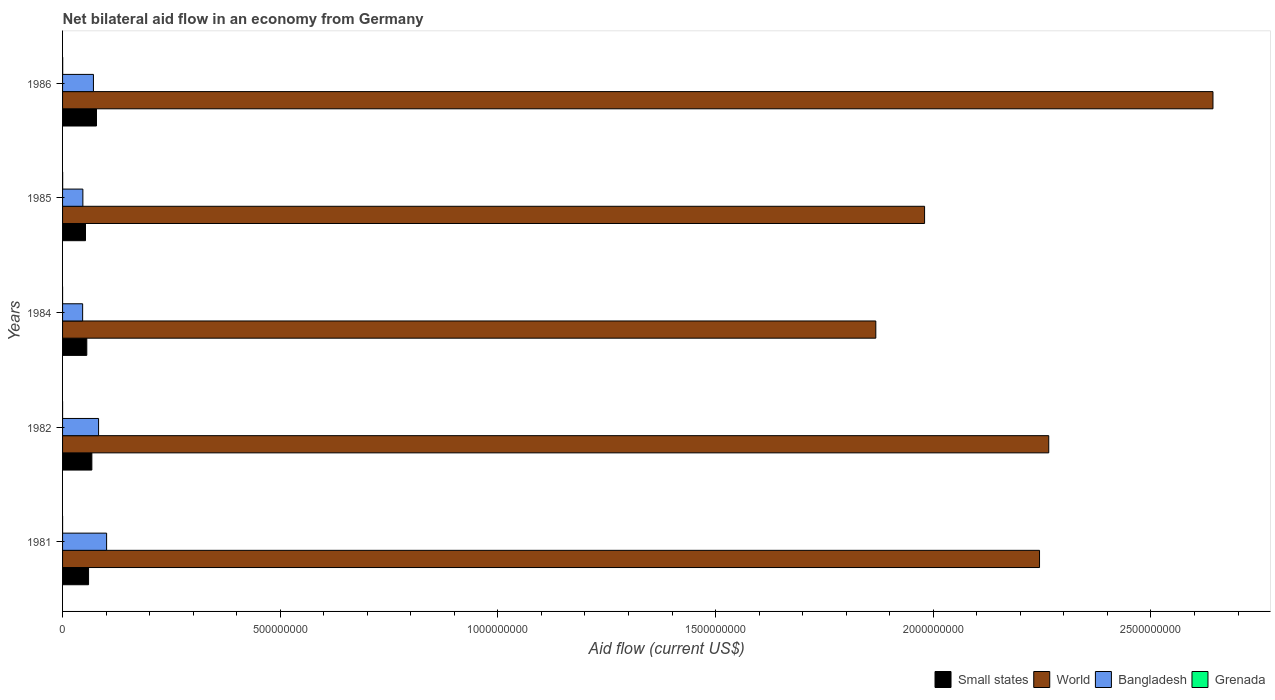Are the number of bars per tick equal to the number of legend labels?
Provide a succinct answer. Yes. How many bars are there on the 4th tick from the bottom?
Your answer should be very brief. 4. What is the label of the 5th group of bars from the top?
Give a very brief answer. 1981. In how many cases, is the number of bars for a given year not equal to the number of legend labels?
Your answer should be compact. 0. What is the net bilateral aid flow in World in 1985?
Provide a short and direct response. 1.98e+09. Across all years, what is the maximum net bilateral aid flow in Small states?
Your response must be concise. 7.79e+07. Across all years, what is the minimum net bilateral aid flow in Small states?
Make the answer very short. 5.27e+07. In which year was the net bilateral aid flow in Small states maximum?
Offer a very short reply. 1986. What is the total net bilateral aid flow in Bangladesh in the graph?
Keep it short and to the point. 3.48e+08. What is the difference between the net bilateral aid flow in Bangladesh in 1981 and the net bilateral aid flow in World in 1985?
Keep it short and to the point. -1.88e+09. What is the average net bilateral aid flow in Small states per year?
Keep it short and to the point. 6.27e+07. In the year 1985, what is the difference between the net bilateral aid flow in World and net bilateral aid flow in Grenada?
Make the answer very short. 1.98e+09. In how many years, is the net bilateral aid flow in Small states greater than 1400000000 US$?
Offer a terse response. 0. What is the ratio of the net bilateral aid flow in Small states in 1982 to that in 1986?
Your answer should be compact. 0.86. Is the difference between the net bilateral aid flow in World in 1981 and 1984 greater than the difference between the net bilateral aid flow in Grenada in 1981 and 1984?
Your answer should be very brief. Yes. What is the difference between the highest and the second highest net bilateral aid flow in Bangladesh?
Provide a short and direct response. 1.85e+07. What is the difference between the highest and the lowest net bilateral aid flow in Bangladesh?
Your response must be concise. 5.51e+07. Is it the case that in every year, the sum of the net bilateral aid flow in Small states and net bilateral aid flow in World is greater than the sum of net bilateral aid flow in Grenada and net bilateral aid flow in Bangladesh?
Keep it short and to the point. Yes. What does the 3rd bar from the top in 1985 represents?
Provide a short and direct response. World. What does the 4th bar from the bottom in 1982 represents?
Your answer should be compact. Grenada. Is it the case that in every year, the sum of the net bilateral aid flow in World and net bilateral aid flow in Bangladesh is greater than the net bilateral aid flow in Grenada?
Your answer should be compact. Yes. What is the difference between two consecutive major ticks on the X-axis?
Give a very brief answer. 5.00e+08. Does the graph contain any zero values?
Make the answer very short. No. Does the graph contain grids?
Your answer should be very brief. No. Where does the legend appear in the graph?
Offer a very short reply. Bottom right. What is the title of the graph?
Make the answer very short. Net bilateral aid flow in an economy from Germany. What is the label or title of the X-axis?
Offer a very short reply. Aid flow (current US$). What is the label or title of the Y-axis?
Offer a very short reply. Years. What is the Aid flow (current US$) of Small states in 1981?
Provide a succinct answer. 5.97e+07. What is the Aid flow (current US$) in World in 1981?
Provide a short and direct response. 2.24e+09. What is the Aid flow (current US$) of Bangladesh in 1981?
Give a very brief answer. 1.01e+08. What is the Aid flow (current US$) in Small states in 1982?
Your answer should be very brief. 6.73e+07. What is the Aid flow (current US$) of World in 1982?
Your answer should be compact. 2.27e+09. What is the Aid flow (current US$) of Bangladesh in 1982?
Offer a terse response. 8.27e+07. What is the Aid flow (current US$) of Grenada in 1982?
Your response must be concise. 4.00e+04. What is the Aid flow (current US$) of Small states in 1984?
Provide a short and direct response. 5.56e+07. What is the Aid flow (current US$) in World in 1984?
Your answer should be compact. 1.87e+09. What is the Aid flow (current US$) in Bangladesh in 1984?
Offer a terse response. 4.61e+07. What is the Aid flow (current US$) in Small states in 1985?
Offer a very short reply. 5.27e+07. What is the Aid flow (current US$) of World in 1985?
Your response must be concise. 1.98e+09. What is the Aid flow (current US$) in Bangladesh in 1985?
Your response must be concise. 4.66e+07. What is the Aid flow (current US$) in Grenada in 1985?
Provide a short and direct response. 2.20e+05. What is the Aid flow (current US$) of Small states in 1986?
Keep it short and to the point. 7.79e+07. What is the Aid flow (current US$) of World in 1986?
Offer a terse response. 2.64e+09. What is the Aid flow (current US$) in Bangladesh in 1986?
Offer a very short reply. 7.09e+07. Across all years, what is the maximum Aid flow (current US$) in Small states?
Give a very brief answer. 7.79e+07. Across all years, what is the maximum Aid flow (current US$) in World?
Give a very brief answer. 2.64e+09. Across all years, what is the maximum Aid flow (current US$) of Bangladesh?
Offer a terse response. 1.01e+08. Across all years, what is the minimum Aid flow (current US$) in Small states?
Keep it short and to the point. 5.27e+07. Across all years, what is the minimum Aid flow (current US$) of World?
Your response must be concise. 1.87e+09. Across all years, what is the minimum Aid flow (current US$) in Bangladesh?
Provide a short and direct response. 4.61e+07. What is the total Aid flow (current US$) of Small states in the graph?
Offer a very short reply. 3.13e+08. What is the total Aid flow (current US$) of World in the graph?
Provide a short and direct response. 1.10e+1. What is the total Aid flow (current US$) in Bangladesh in the graph?
Ensure brevity in your answer.  3.48e+08. What is the total Aid flow (current US$) of Grenada in the graph?
Make the answer very short. 5.70e+05. What is the difference between the Aid flow (current US$) of Small states in 1981 and that in 1982?
Offer a terse response. -7.58e+06. What is the difference between the Aid flow (current US$) in World in 1981 and that in 1982?
Offer a very short reply. -2.12e+07. What is the difference between the Aid flow (current US$) of Bangladesh in 1981 and that in 1982?
Offer a terse response. 1.85e+07. What is the difference between the Aid flow (current US$) in Grenada in 1981 and that in 1982?
Offer a very short reply. -10000. What is the difference between the Aid flow (current US$) of Small states in 1981 and that in 1984?
Make the answer very short. 4.07e+06. What is the difference between the Aid flow (current US$) of World in 1981 and that in 1984?
Provide a short and direct response. 3.76e+08. What is the difference between the Aid flow (current US$) of Bangladesh in 1981 and that in 1984?
Your answer should be compact. 5.51e+07. What is the difference between the Aid flow (current US$) of Small states in 1981 and that in 1985?
Keep it short and to the point. 7.04e+06. What is the difference between the Aid flow (current US$) in World in 1981 and that in 1985?
Offer a terse response. 2.64e+08. What is the difference between the Aid flow (current US$) of Bangladesh in 1981 and that in 1985?
Provide a short and direct response. 5.45e+07. What is the difference between the Aid flow (current US$) in Grenada in 1981 and that in 1985?
Your answer should be compact. -1.90e+05. What is the difference between the Aid flow (current US$) of Small states in 1981 and that in 1986?
Provide a short and direct response. -1.82e+07. What is the difference between the Aid flow (current US$) of World in 1981 and that in 1986?
Your answer should be very brief. -3.98e+08. What is the difference between the Aid flow (current US$) in Bangladesh in 1981 and that in 1986?
Ensure brevity in your answer.  3.03e+07. What is the difference between the Aid flow (current US$) of Small states in 1982 and that in 1984?
Offer a terse response. 1.16e+07. What is the difference between the Aid flow (current US$) in World in 1982 and that in 1984?
Your answer should be very brief. 3.97e+08. What is the difference between the Aid flow (current US$) of Bangladesh in 1982 and that in 1984?
Provide a short and direct response. 3.66e+07. What is the difference between the Aid flow (current US$) of Grenada in 1982 and that in 1984?
Give a very brief answer. 3.00e+04. What is the difference between the Aid flow (current US$) in Small states in 1982 and that in 1985?
Make the answer very short. 1.46e+07. What is the difference between the Aid flow (current US$) in World in 1982 and that in 1985?
Your answer should be very brief. 2.85e+08. What is the difference between the Aid flow (current US$) in Bangladesh in 1982 and that in 1985?
Offer a terse response. 3.61e+07. What is the difference between the Aid flow (current US$) in Small states in 1982 and that in 1986?
Provide a short and direct response. -1.06e+07. What is the difference between the Aid flow (current US$) in World in 1982 and that in 1986?
Your answer should be compact. -3.77e+08. What is the difference between the Aid flow (current US$) of Bangladesh in 1982 and that in 1986?
Offer a very short reply. 1.18e+07. What is the difference between the Aid flow (current US$) of Grenada in 1982 and that in 1986?
Keep it short and to the point. -2.30e+05. What is the difference between the Aid flow (current US$) in Small states in 1984 and that in 1985?
Provide a short and direct response. 2.97e+06. What is the difference between the Aid flow (current US$) in World in 1984 and that in 1985?
Your answer should be very brief. -1.12e+08. What is the difference between the Aid flow (current US$) of Bangladesh in 1984 and that in 1985?
Offer a very short reply. -5.20e+05. What is the difference between the Aid flow (current US$) of Grenada in 1984 and that in 1985?
Provide a succinct answer. -2.10e+05. What is the difference between the Aid flow (current US$) of Small states in 1984 and that in 1986?
Ensure brevity in your answer.  -2.23e+07. What is the difference between the Aid flow (current US$) of World in 1984 and that in 1986?
Your response must be concise. -7.74e+08. What is the difference between the Aid flow (current US$) in Bangladesh in 1984 and that in 1986?
Give a very brief answer. -2.48e+07. What is the difference between the Aid flow (current US$) of Small states in 1985 and that in 1986?
Your answer should be compact. -2.52e+07. What is the difference between the Aid flow (current US$) of World in 1985 and that in 1986?
Offer a very short reply. -6.62e+08. What is the difference between the Aid flow (current US$) of Bangladesh in 1985 and that in 1986?
Provide a succinct answer. -2.43e+07. What is the difference between the Aid flow (current US$) of Grenada in 1985 and that in 1986?
Make the answer very short. -5.00e+04. What is the difference between the Aid flow (current US$) in Small states in 1981 and the Aid flow (current US$) in World in 1982?
Give a very brief answer. -2.21e+09. What is the difference between the Aid flow (current US$) of Small states in 1981 and the Aid flow (current US$) of Bangladesh in 1982?
Ensure brevity in your answer.  -2.30e+07. What is the difference between the Aid flow (current US$) in Small states in 1981 and the Aid flow (current US$) in Grenada in 1982?
Give a very brief answer. 5.97e+07. What is the difference between the Aid flow (current US$) in World in 1981 and the Aid flow (current US$) in Bangladesh in 1982?
Offer a terse response. 2.16e+09. What is the difference between the Aid flow (current US$) in World in 1981 and the Aid flow (current US$) in Grenada in 1982?
Your answer should be compact. 2.24e+09. What is the difference between the Aid flow (current US$) in Bangladesh in 1981 and the Aid flow (current US$) in Grenada in 1982?
Your answer should be very brief. 1.01e+08. What is the difference between the Aid flow (current US$) of Small states in 1981 and the Aid flow (current US$) of World in 1984?
Provide a short and direct response. -1.81e+09. What is the difference between the Aid flow (current US$) of Small states in 1981 and the Aid flow (current US$) of Bangladesh in 1984?
Keep it short and to the point. 1.36e+07. What is the difference between the Aid flow (current US$) in Small states in 1981 and the Aid flow (current US$) in Grenada in 1984?
Provide a succinct answer. 5.97e+07. What is the difference between the Aid flow (current US$) of World in 1981 and the Aid flow (current US$) of Bangladesh in 1984?
Offer a terse response. 2.20e+09. What is the difference between the Aid flow (current US$) in World in 1981 and the Aid flow (current US$) in Grenada in 1984?
Provide a short and direct response. 2.24e+09. What is the difference between the Aid flow (current US$) in Bangladesh in 1981 and the Aid flow (current US$) in Grenada in 1984?
Offer a very short reply. 1.01e+08. What is the difference between the Aid flow (current US$) in Small states in 1981 and the Aid flow (current US$) in World in 1985?
Provide a succinct answer. -1.92e+09. What is the difference between the Aid flow (current US$) in Small states in 1981 and the Aid flow (current US$) in Bangladesh in 1985?
Provide a short and direct response. 1.31e+07. What is the difference between the Aid flow (current US$) of Small states in 1981 and the Aid flow (current US$) of Grenada in 1985?
Make the answer very short. 5.95e+07. What is the difference between the Aid flow (current US$) in World in 1981 and the Aid flow (current US$) in Bangladesh in 1985?
Offer a terse response. 2.20e+09. What is the difference between the Aid flow (current US$) of World in 1981 and the Aid flow (current US$) of Grenada in 1985?
Your answer should be very brief. 2.24e+09. What is the difference between the Aid flow (current US$) in Bangladesh in 1981 and the Aid flow (current US$) in Grenada in 1985?
Give a very brief answer. 1.01e+08. What is the difference between the Aid flow (current US$) in Small states in 1981 and the Aid flow (current US$) in World in 1986?
Provide a succinct answer. -2.58e+09. What is the difference between the Aid flow (current US$) in Small states in 1981 and the Aid flow (current US$) in Bangladesh in 1986?
Keep it short and to the point. -1.12e+07. What is the difference between the Aid flow (current US$) in Small states in 1981 and the Aid flow (current US$) in Grenada in 1986?
Provide a short and direct response. 5.94e+07. What is the difference between the Aid flow (current US$) in World in 1981 and the Aid flow (current US$) in Bangladesh in 1986?
Keep it short and to the point. 2.17e+09. What is the difference between the Aid flow (current US$) of World in 1981 and the Aid flow (current US$) of Grenada in 1986?
Give a very brief answer. 2.24e+09. What is the difference between the Aid flow (current US$) in Bangladesh in 1981 and the Aid flow (current US$) in Grenada in 1986?
Your response must be concise. 1.01e+08. What is the difference between the Aid flow (current US$) of Small states in 1982 and the Aid flow (current US$) of World in 1984?
Provide a short and direct response. -1.80e+09. What is the difference between the Aid flow (current US$) in Small states in 1982 and the Aid flow (current US$) in Bangladesh in 1984?
Provide a succinct answer. 2.12e+07. What is the difference between the Aid flow (current US$) of Small states in 1982 and the Aid flow (current US$) of Grenada in 1984?
Keep it short and to the point. 6.73e+07. What is the difference between the Aid flow (current US$) of World in 1982 and the Aid flow (current US$) of Bangladesh in 1984?
Provide a short and direct response. 2.22e+09. What is the difference between the Aid flow (current US$) in World in 1982 and the Aid flow (current US$) in Grenada in 1984?
Keep it short and to the point. 2.27e+09. What is the difference between the Aid flow (current US$) of Bangladesh in 1982 and the Aid flow (current US$) of Grenada in 1984?
Make the answer very short. 8.27e+07. What is the difference between the Aid flow (current US$) in Small states in 1982 and the Aid flow (current US$) in World in 1985?
Your answer should be compact. -1.91e+09. What is the difference between the Aid flow (current US$) of Small states in 1982 and the Aid flow (current US$) of Bangladesh in 1985?
Give a very brief answer. 2.07e+07. What is the difference between the Aid flow (current US$) of Small states in 1982 and the Aid flow (current US$) of Grenada in 1985?
Your answer should be very brief. 6.71e+07. What is the difference between the Aid flow (current US$) of World in 1982 and the Aid flow (current US$) of Bangladesh in 1985?
Offer a very short reply. 2.22e+09. What is the difference between the Aid flow (current US$) in World in 1982 and the Aid flow (current US$) in Grenada in 1985?
Provide a short and direct response. 2.27e+09. What is the difference between the Aid flow (current US$) of Bangladesh in 1982 and the Aid flow (current US$) of Grenada in 1985?
Your answer should be compact. 8.25e+07. What is the difference between the Aid flow (current US$) of Small states in 1982 and the Aid flow (current US$) of World in 1986?
Give a very brief answer. -2.58e+09. What is the difference between the Aid flow (current US$) in Small states in 1982 and the Aid flow (current US$) in Bangladesh in 1986?
Your answer should be compact. -3.60e+06. What is the difference between the Aid flow (current US$) in Small states in 1982 and the Aid flow (current US$) in Grenada in 1986?
Keep it short and to the point. 6.70e+07. What is the difference between the Aid flow (current US$) in World in 1982 and the Aid flow (current US$) in Bangladesh in 1986?
Your answer should be very brief. 2.19e+09. What is the difference between the Aid flow (current US$) in World in 1982 and the Aid flow (current US$) in Grenada in 1986?
Your response must be concise. 2.26e+09. What is the difference between the Aid flow (current US$) of Bangladesh in 1982 and the Aid flow (current US$) of Grenada in 1986?
Your response must be concise. 8.24e+07. What is the difference between the Aid flow (current US$) in Small states in 1984 and the Aid flow (current US$) in World in 1985?
Offer a very short reply. -1.92e+09. What is the difference between the Aid flow (current US$) of Small states in 1984 and the Aid flow (current US$) of Bangladesh in 1985?
Your answer should be compact. 9.01e+06. What is the difference between the Aid flow (current US$) of Small states in 1984 and the Aid flow (current US$) of Grenada in 1985?
Make the answer very short. 5.54e+07. What is the difference between the Aid flow (current US$) of World in 1984 and the Aid flow (current US$) of Bangladesh in 1985?
Ensure brevity in your answer.  1.82e+09. What is the difference between the Aid flow (current US$) of World in 1984 and the Aid flow (current US$) of Grenada in 1985?
Give a very brief answer. 1.87e+09. What is the difference between the Aid flow (current US$) of Bangladesh in 1984 and the Aid flow (current US$) of Grenada in 1985?
Your answer should be very brief. 4.59e+07. What is the difference between the Aid flow (current US$) in Small states in 1984 and the Aid flow (current US$) in World in 1986?
Offer a very short reply. -2.59e+09. What is the difference between the Aid flow (current US$) in Small states in 1984 and the Aid flow (current US$) in Bangladesh in 1986?
Offer a very short reply. -1.52e+07. What is the difference between the Aid flow (current US$) in Small states in 1984 and the Aid flow (current US$) in Grenada in 1986?
Your answer should be compact. 5.54e+07. What is the difference between the Aid flow (current US$) of World in 1984 and the Aid flow (current US$) of Bangladesh in 1986?
Provide a succinct answer. 1.80e+09. What is the difference between the Aid flow (current US$) of World in 1984 and the Aid flow (current US$) of Grenada in 1986?
Your response must be concise. 1.87e+09. What is the difference between the Aid flow (current US$) of Bangladesh in 1984 and the Aid flow (current US$) of Grenada in 1986?
Provide a succinct answer. 4.58e+07. What is the difference between the Aid flow (current US$) of Small states in 1985 and the Aid flow (current US$) of World in 1986?
Provide a succinct answer. -2.59e+09. What is the difference between the Aid flow (current US$) in Small states in 1985 and the Aid flow (current US$) in Bangladesh in 1986?
Provide a succinct answer. -1.82e+07. What is the difference between the Aid flow (current US$) of Small states in 1985 and the Aid flow (current US$) of Grenada in 1986?
Offer a very short reply. 5.24e+07. What is the difference between the Aid flow (current US$) of World in 1985 and the Aid flow (current US$) of Bangladesh in 1986?
Make the answer very short. 1.91e+09. What is the difference between the Aid flow (current US$) of World in 1985 and the Aid flow (current US$) of Grenada in 1986?
Offer a terse response. 1.98e+09. What is the difference between the Aid flow (current US$) in Bangladesh in 1985 and the Aid flow (current US$) in Grenada in 1986?
Keep it short and to the point. 4.64e+07. What is the average Aid flow (current US$) of Small states per year?
Give a very brief answer. 6.27e+07. What is the average Aid flow (current US$) in World per year?
Give a very brief answer. 2.20e+09. What is the average Aid flow (current US$) of Bangladesh per year?
Provide a short and direct response. 6.95e+07. What is the average Aid flow (current US$) in Grenada per year?
Your answer should be compact. 1.14e+05. In the year 1981, what is the difference between the Aid flow (current US$) of Small states and Aid flow (current US$) of World?
Ensure brevity in your answer.  -2.18e+09. In the year 1981, what is the difference between the Aid flow (current US$) of Small states and Aid flow (current US$) of Bangladesh?
Provide a short and direct response. -4.15e+07. In the year 1981, what is the difference between the Aid flow (current US$) in Small states and Aid flow (current US$) in Grenada?
Ensure brevity in your answer.  5.97e+07. In the year 1981, what is the difference between the Aid flow (current US$) in World and Aid flow (current US$) in Bangladesh?
Make the answer very short. 2.14e+09. In the year 1981, what is the difference between the Aid flow (current US$) of World and Aid flow (current US$) of Grenada?
Offer a terse response. 2.24e+09. In the year 1981, what is the difference between the Aid flow (current US$) in Bangladesh and Aid flow (current US$) in Grenada?
Your answer should be compact. 1.01e+08. In the year 1982, what is the difference between the Aid flow (current US$) of Small states and Aid flow (current US$) of World?
Your answer should be compact. -2.20e+09. In the year 1982, what is the difference between the Aid flow (current US$) of Small states and Aid flow (current US$) of Bangladesh?
Make the answer very short. -1.54e+07. In the year 1982, what is the difference between the Aid flow (current US$) in Small states and Aid flow (current US$) in Grenada?
Give a very brief answer. 6.73e+07. In the year 1982, what is the difference between the Aid flow (current US$) in World and Aid flow (current US$) in Bangladesh?
Provide a short and direct response. 2.18e+09. In the year 1982, what is the difference between the Aid flow (current US$) of World and Aid flow (current US$) of Grenada?
Ensure brevity in your answer.  2.27e+09. In the year 1982, what is the difference between the Aid flow (current US$) of Bangladesh and Aid flow (current US$) of Grenada?
Offer a very short reply. 8.27e+07. In the year 1984, what is the difference between the Aid flow (current US$) in Small states and Aid flow (current US$) in World?
Your answer should be very brief. -1.81e+09. In the year 1984, what is the difference between the Aid flow (current US$) of Small states and Aid flow (current US$) of Bangladesh?
Provide a succinct answer. 9.53e+06. In the year 1984, what is the difference between the Aid flow (current US$) in Small states and Aid flow (current US$) in Grenada?
Your answer should be very brief. 5.56e+07. In the year 1984, what is the difference between the Aid flow (current US$) of World and Aid flow (current US$) of Bangladesh?
Offer a very short reply. 1.82e+09. In the year 1984, what is the difference between the Aid flow (current US$) of World and Aid flow (current US$) of Grenada?
Give a very brief answer. 1.87e+09. In the year 1984, what is the difference between the Aid flow (current US$) in Bangladesh and Aid flow (current US$) in Grenada?
Offer a terse response. 4.61e+07. In the year 1985, what is the difference between the Aid flow (current US$) in Small states and Aid flow (current US$) in World?
Your answer should be compact. -1.93e+09. In the year 1985, what is the difference between the Aid flow (current US$) of Small states and Aid flow (current US$) of Bangladesh?
Give a very brief answer. 6.04e+06. In the year 1985, what is the difference between the Aid flow (current US$) of Small states and Aid flow (current US$) of Grenada?
Your answer should be very brief. 5.25e+07. In the year 1985, what is the difference between the Aid flow (current US$) of World and Aid flow (current US$) of Bangladesh?
Your answer should be very brief. 1.93e+09. In the year 1985, what is the difference between the Aid flow (current US$) in World and Aid flow (current US$) in Grenada?
Offer a very short reply. 1.98e+09. In the year 1985, what is the difference between the Aid flow (current US$) in Bangladesh and Aid flow (current US$) in Grenada?
Keep it short and to the point. 4.64e+07. In the year 1986, what is the difference between the Aid flow (current US$) in Small states and Aid flow (current US$) in World?
Keep it short and to the point. -2.56e+09. In the year 1986, what is the difference between the Aid flow (current US$) of Small states and Aid flow (current US$) of Bangladesh?
Provide a short and direct response. 7.01e+06. In the year 1986, what is the difference between the Aid flow (current US$) of Small states and Aid flow (current US$) of Grenada?
Offer a terse response. 7.76e+07. In the year 1986, what is the difference between the Aid flow (current US$) in World and Aid flow (current US$) in Bangladesh?
Your answer should be compact. 2.57e+09. In the year 1986, what is the difference between the Aid flow (current US$) of World and Aid flow (current US$) of Grenada?
Offer a very short reply. 2.64e+09. In the year 1986, what is the difference between the Aid flow (current US$) of Bangladesh and Aid flow (current US$) of Grenada?
Give a very brief answer. 7.06e+07. What is the ratio of the Aid flow (current US$) in Small states in 1981 to that in 1982?
Your answer should be very brief. 0.89. What is the ratio of the Aid flow (current US$) in Bangladesh in 1981 to that in 1982?
Provide a short and direct response. 1.22. What is the ratio of the Aid flow (current US$) in Small states in 1981 to that in 1984?
Offer a very short reply. 1.07. What is the ratio of the Aid flow (current US$) of World in 1981 to that in 1984?
Give a very brief answer. 1.2. What is the ratio of the Aid flow (current US$) in Bangladesh in 1981 to that in 1984?
Provide a short and direct response. 2.19. What is the ratio of the Aid flow (current US$) of Grenada in 1981 to that in 1984?
Your answer should be very brief. 3. What is the ratio of the Aid flow (current US$) of Small states in 1981 to that in 1985?
Your response must be concise. 1.13. What is the ratio of the Aid flow (current US$) in World in 1981 to that in 1985?
Make the answer very short. 1.13. What is the ratio of the Aid flow (current US$) in Bangladesh in 1981 to that in 1985?
Make the answer very short. 2.17. What is the ratio of the Aid flow (current US$) of Grenada in 1981 to that in 1985?
Your response must be concise. 0.14. What is the ratio of the Aid flow (current US$) in Small states in 1981 to that in 1986?
Offer a terse response. 0.77. What is the ratio of the Aid flow (current US$) in World in 1981 to that in 1986?
Offer a terse response. 0.85. What is the ratio of the Aid flow (current US$) of Bangladesh in 1981 to that in 1986?
Offer a very short reply. 1.43. What is the ratio of the Aid flow (current US$) in Small states in 1982 to that in 1984?
Offer a very short reply. 1.21. What is the ratio of the Aid flow (current US$) of World in 1982 to that in 1984?
Make the answer very short. 1.21. What is the ratio of the Aid flow (current US$) of Bangladesh in 1982 to that in 1984?
Your response must be concise. 1.79. What is the ratio of the Aid flow (current US$) in Small states in 1982 to that in 1985?
Provide a short and direct response. 1.28. What is the ratio of the Aid flow (current US$) of World in 1982 to that in 1985?
Provide a succinct answer. 1.14. What is the ratio of the Aid flow (current US$) in Bangladesh in 1982 to that in 1985?
Offer a terse response. 1.77. What is the ratio of the Aid flow (current US$) of Grenada in 1982 to that in 1985?
Provide a succinct answer. 0.18. What is the ratio of the Aid flow (current US$) of Small states in 1982 to that in 1986?
Ensure brevity in your answer.  0.86. What is the ratio of the Aid flow (current US$) of World in 1982 to that in 1986?
Provide a succinct answer. 0.86. What is the ratio of the Aid flow (current US$) in Bangladesh in 1982 to that in 1986?
Ensure brevity in your answer.  1.17. What is the ratio of the Aid flow (current US$) of Grenada in 1982 to that in 1986?
Offer a very short reply. 0.15. What is the ratio of the Aid flow (current US$) of Small states in 1984 to that in 1985?
Make the answer very short. 1.06. What is the ratio of the Aid flow (current US$) of World in 1984 to that in 1985?
Provide a succinct answer. 0.94. What is the ratio of the Aid flow (current US$) in Bangladesh in 1984 to that in 1985?
Offer a very short reply. 0.99. What is the ratio of the Aid flow (current US$) of Grenada in 1984 to that in 1985?
Your answer should be compact. 0.05. What is the ratio of the Aid flow (current US$) in Small states in 1984 to that in 1986?
Provide a short and direct response. 0.71. What is the ratio of the Aid flow (current US$) in World in 1984 to that in 1986?
Ensure brevity in your answer.  0.71. What is the ratio of the Aid flow (current US$) of Bangladesh in 1984 to that in 1986?
Offer a terse response. 0.65. What is the ratio of the Aid flow (current US$) of Grenada in 1984 to that in 1986?
Make the answer very short. 0.04. What is the ratio of the Aid flow (current US$) in Small states in 1985 to that in 1986?
Your answer should be very brief. 0.68. What is the ratio of the Aid flow (current US$) of World in 1985 to that in 1986?
Your answer should be very brief. 0.75. What is the ratio of the Aid flow (current US$) in Bangladesh in 1985 to that in 1986?
Make the answer very short. 0.66. What is the ratio of the Aid flow (current US$) of Grenada in 1985 to that in 1986?
Provide a succinct answer. 0.81. What is the difference between the highest and the second highest Aid flow (current US$) of Small states?
Ensure brevity in your answer.  1.06e+07. What is the difference between the highest and the second highest Aid flow (current US$) in World?
Ensure brevity in your answer.  3.77e+08. What is the difference between the highest and the second highest Aid flow (current US$) in Bangladesh?
Provide a short and direct response. 1.85e+07. What is the difference between the highest and the second highest Aid flow (current US$) of Grenada?
Give a very brief answer. 5.00e+04. What is the difference between the highest and the lowest Aid flow (current US$) in Small states?
Ensure brevity in your answer.  2.52e+07. What is the difference between the highest and the lowest Aid flow (current US$) of World?
Make the answer very short. 7.74e+08. What is the difference between the highest and the lowest Aid flow (current US$) of Bangladesh?
Your response must be concise. 5.51e+07. 